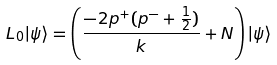<formula> <loc_0><loc_0><loc_500><loc_500>L _ { 0 } | \psi \rangle = \left ( \frac { - 2 p ^ { + } ( p ^ { - } + \frac { 1 } { 2 } ) } { k } + N \right ) | \psi \rangle</formula> 